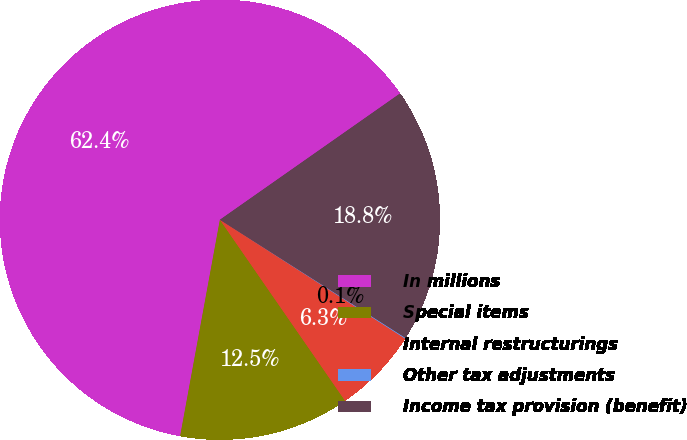Convert chart. <chart><loc_0><loc_0><loc_500><loc_500><pie_chart><fcel>In millions<fcel>Special items<fcel>Internal restructurings<fcel>Other tax adjustments<fcel>Income tax provision (benefit)<nl><fcel>62.37%<fcel>12.52%<fcel>6.29%<fcel>0.06%<fcel>18.75%<nl></chart> 